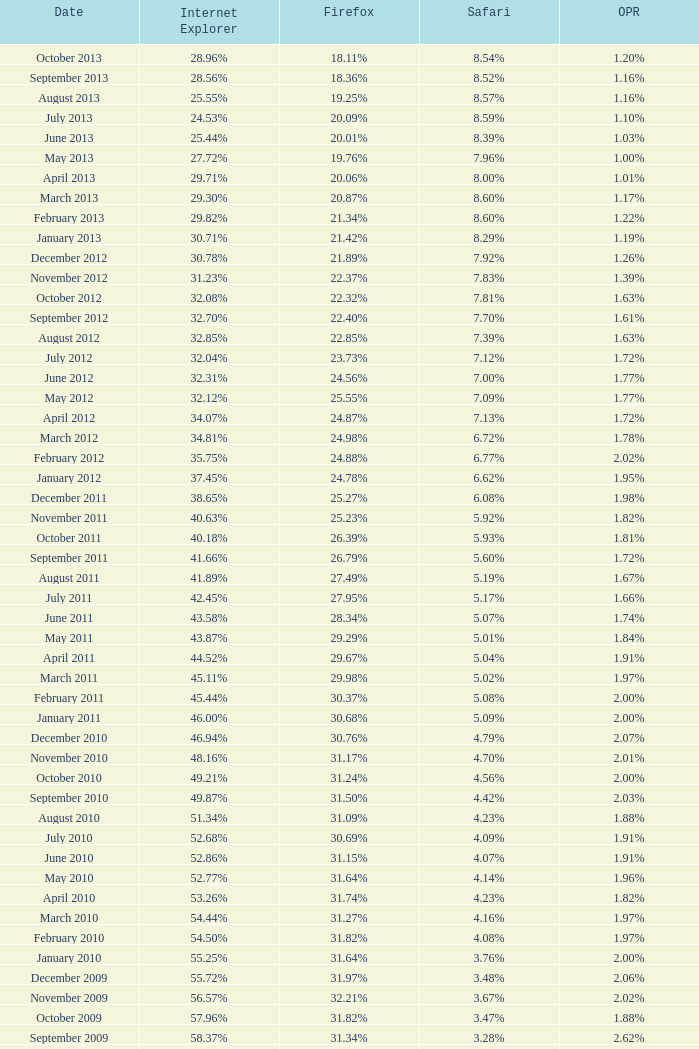What percentage of browsers were using Opera in October 2010? 2.00%. 